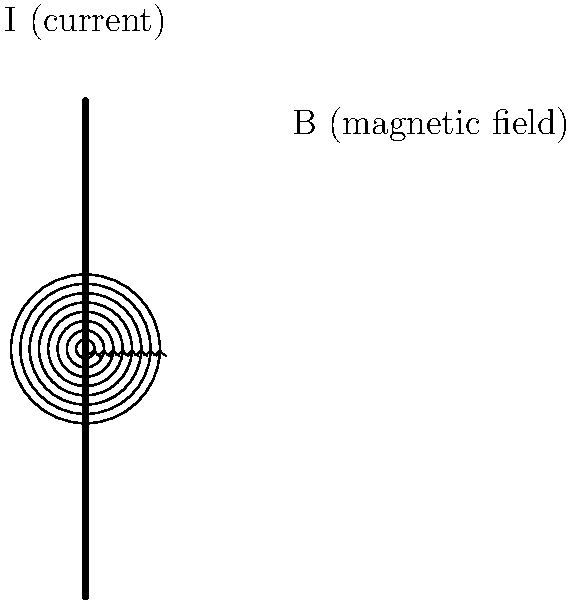Consider a long, straight wire carrying a current I as shown in the figure. According to the right-hand rule, in which direction do the magnetic field lines circulate around the wire? To determine the direction of the magnetic field lines around a current-carrying wire, we can use the right-hand rule. This rule is a method for visualizing the relationship between the direction of current flow and the resulting magnetic field. Here's how to apply it:

1. Imagine grasping the wire with your right hand, with your thumb pointing in the direction of the conventional current (from positive to negative).

2. When you do this, your fingers will naturally curl around the wire.

3. The direction in which your fingers curl represents the direction of the magnetic field lines around the wire.

In the given figure:

- The current I is flowing upwards (indicated by the arrow).
- The magnetic field lines are represented by circular arrows around the wire.

Applying the right-hand rule:

- If we point our right thumb upwards (in the direction of the current),
- Our fingers will curl around the wire in a counterclockwise direction when viewed from above.

Therefore, the magnetic field lines circulate counterclockwise around the wire when viewed from above (or clockwise when viewed from below).

This circulation is consistent with the arrows shown in the figure, which indicate a counterclockwise rotation around the wire.
Answer: Counterclockwise (when viewed from above) 